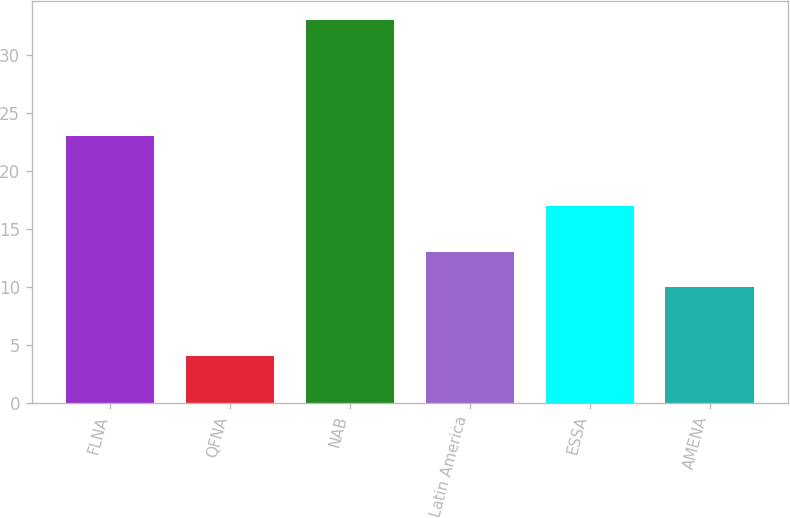Convert chart to OTSL. <chart><loc_0><loc_0><loc_500><loc_500><bar_chart><fcel>FLNA<fcel>QFNA<fcel>NAB<fcel>Latin America<fcel>ESSA<fcel>AMENA<nl><fcel>23<fcel>4<fcel>33<fcel>13<fcel>17<fcel>10<nl></chart> 